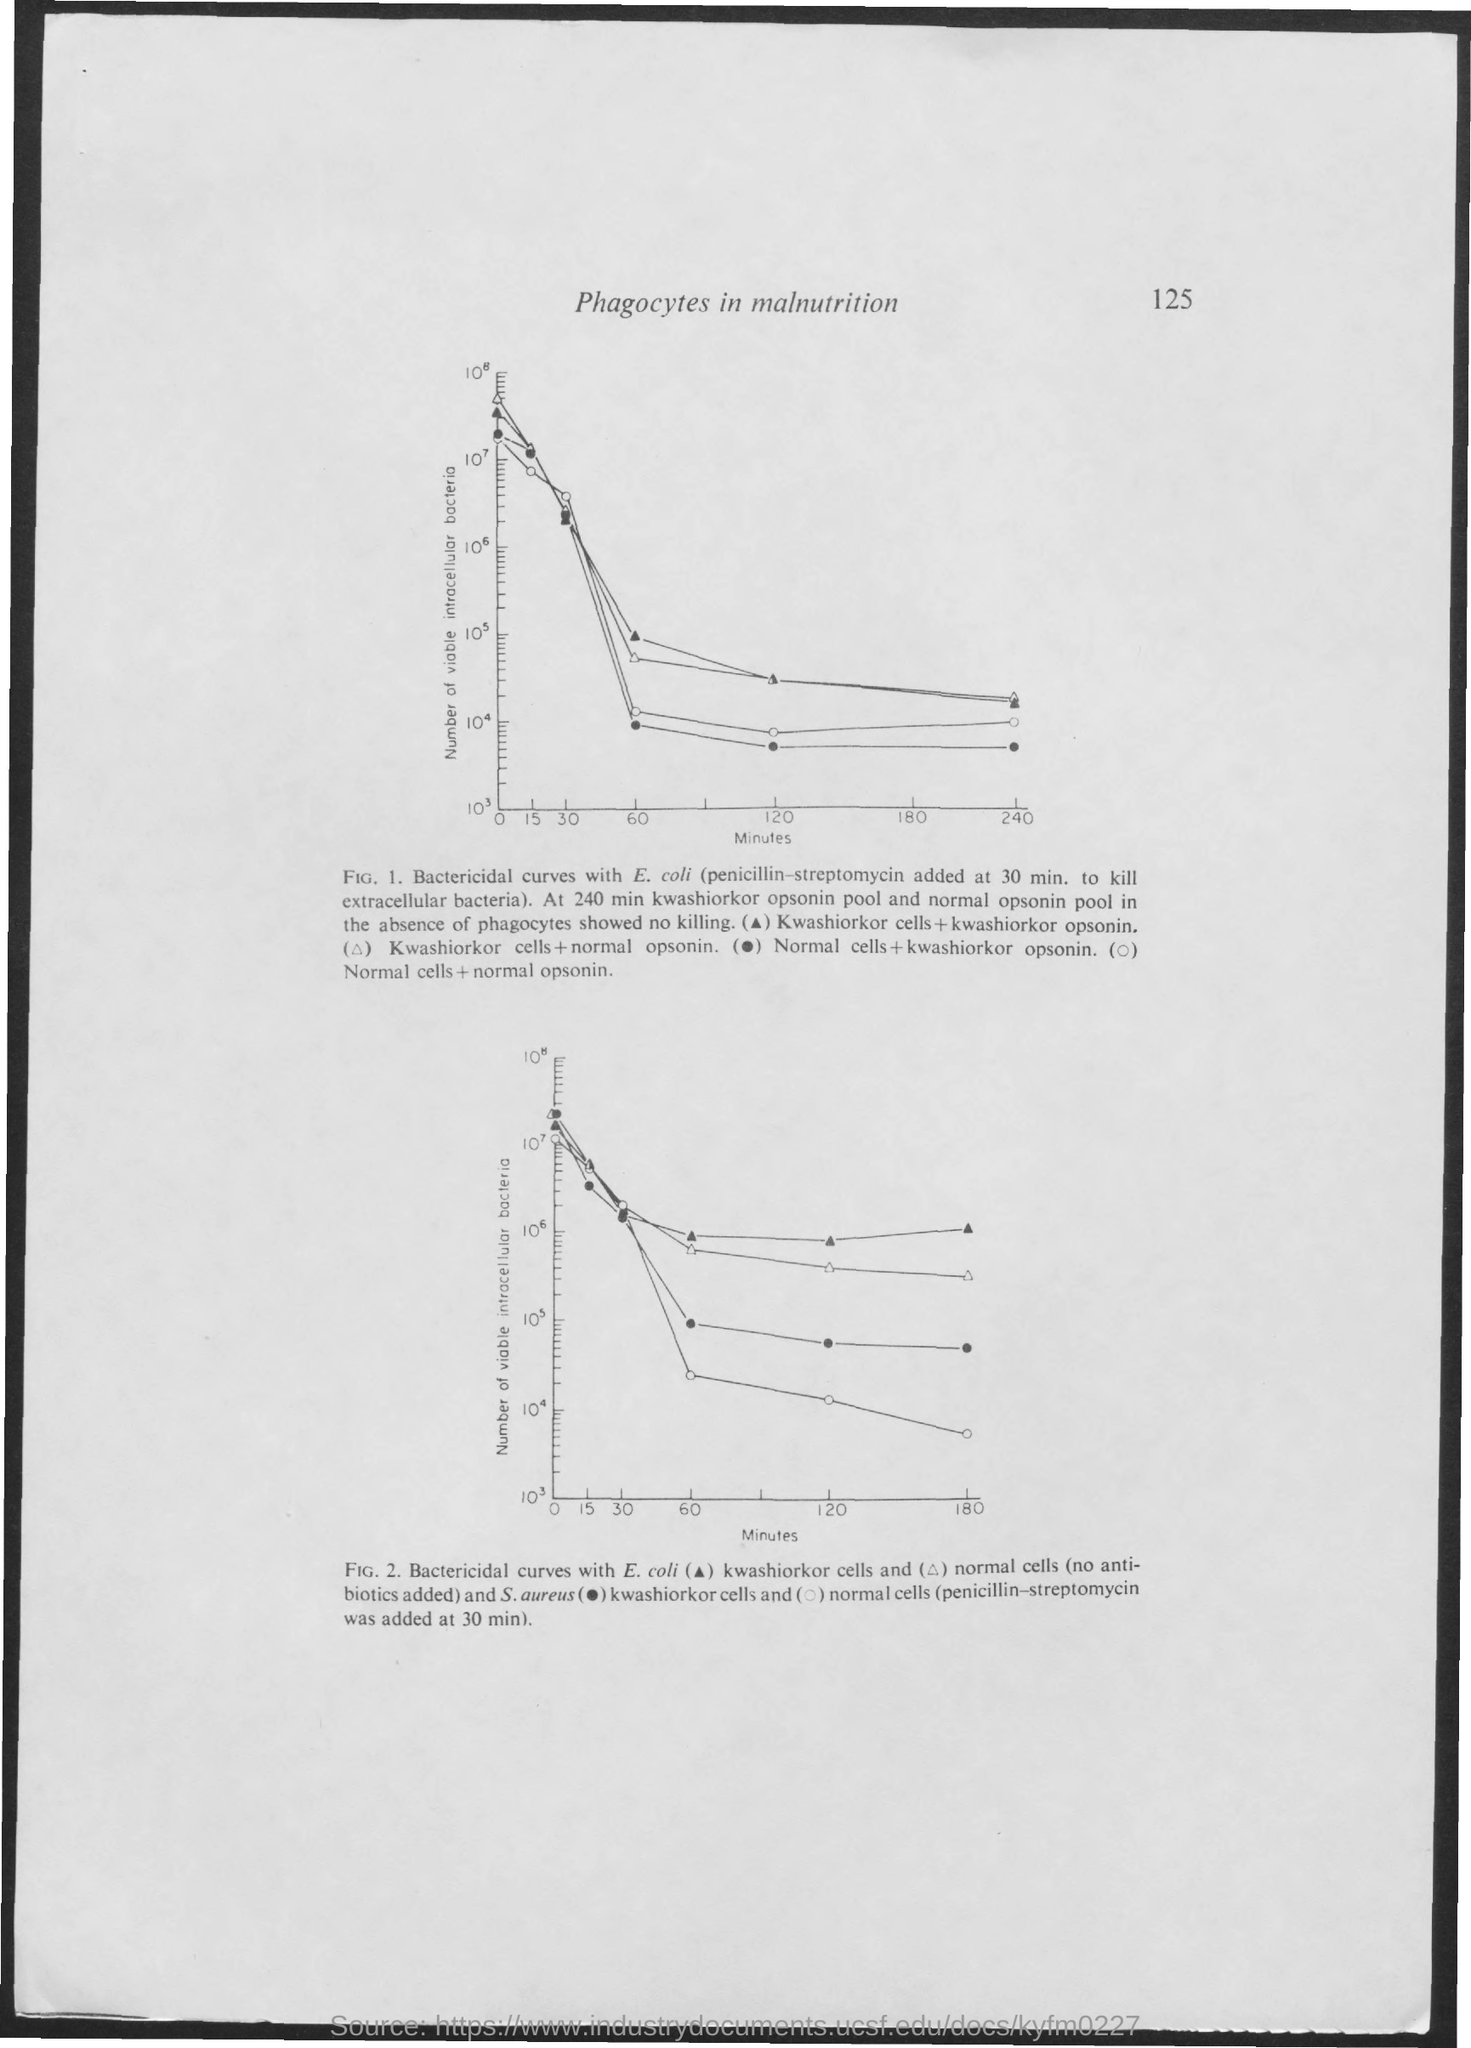What is the page title?
Offer a terse response. Phagocytes in malnutrition. What is the page number?
Give a very brief answer. 125. What is the X-axis in Fig 1?
Offer a very short reply. Minutes. 